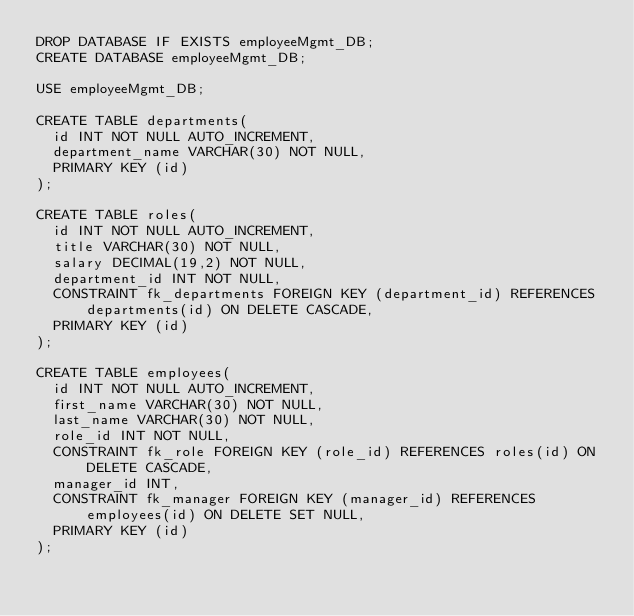Convert code to text. <code><loc_0><loc_0><loc_500><loc_500><_SQL_>DROP DATABASE IF EXISTS employeeMgmt_DB;
CREATE DATABASE employeeMgmt_DB;

USE employeeMgmt_DB;

CREATE TABLE departments(
  id INT NOT NULL AUTO_INCREMENT,
  department_name VARCHAR(30) NOT NULL,
  PRIMARY KEY (id)
);

CREATE TABLE roles(
  id INT NOT NULL AUTO_INCREMENT,
  title VARCHAR(30) NOT NULL,
  salary DECIMAL(19,2) NOT NULL,
  department_id INT NOT NULL,
  CONSTRAINT fk_departments FOREIGN KEY (department_id) REFERENCES departments(id) ON DELETE CASCADE,
  PRIMARY KEY (id)
);

CREATE TABLE employees(
  id INT NOT NULL AUTO_INCREMENT,
  first_name VARCHAR(30) NOT NULL,
  last_name VARCHAR(30) NOT NULL,
  role_id INT NOT NULL,
  CONSTRAINT fk_role FOREIGN KEY (role_id) REFERENCES roles(id) ON DELETE CASCADE,
  manager_id INT,
  CONSTRAINT fk_manager FOREIGN KEY (manager_id) REFERENCES employees(id) ON DELETE SET NULL,
  PRIMARY KEY (id)
);


</code> 